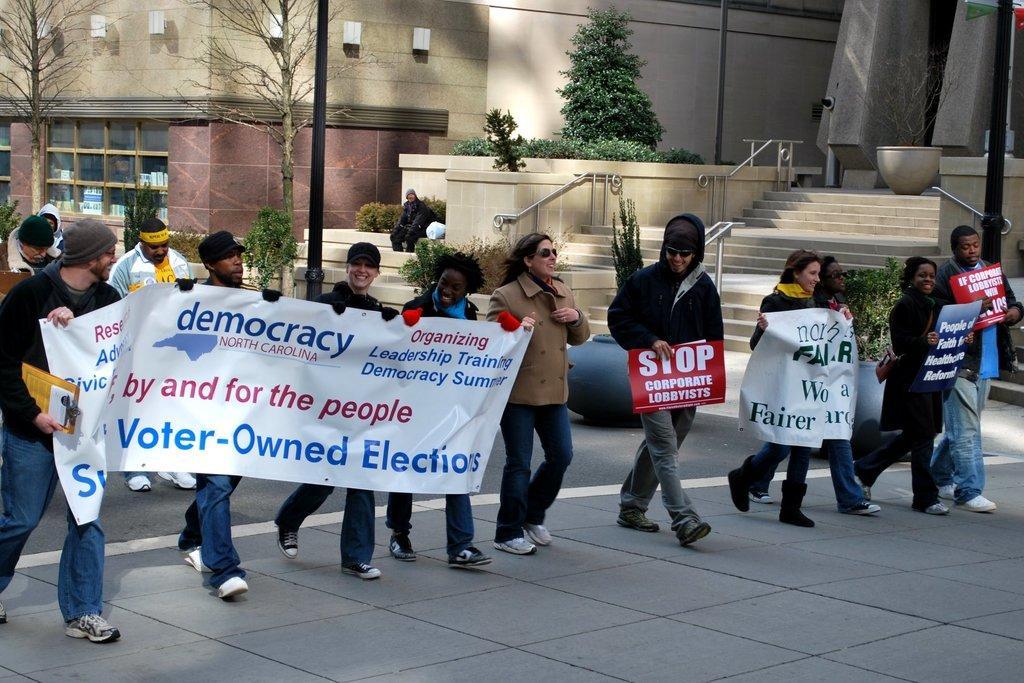How would you summarize this image in a sentence or two? In this image we can see people are holding banners. There are plants, trees, steps, poles, pots, and a person. In the background there are buildings. 